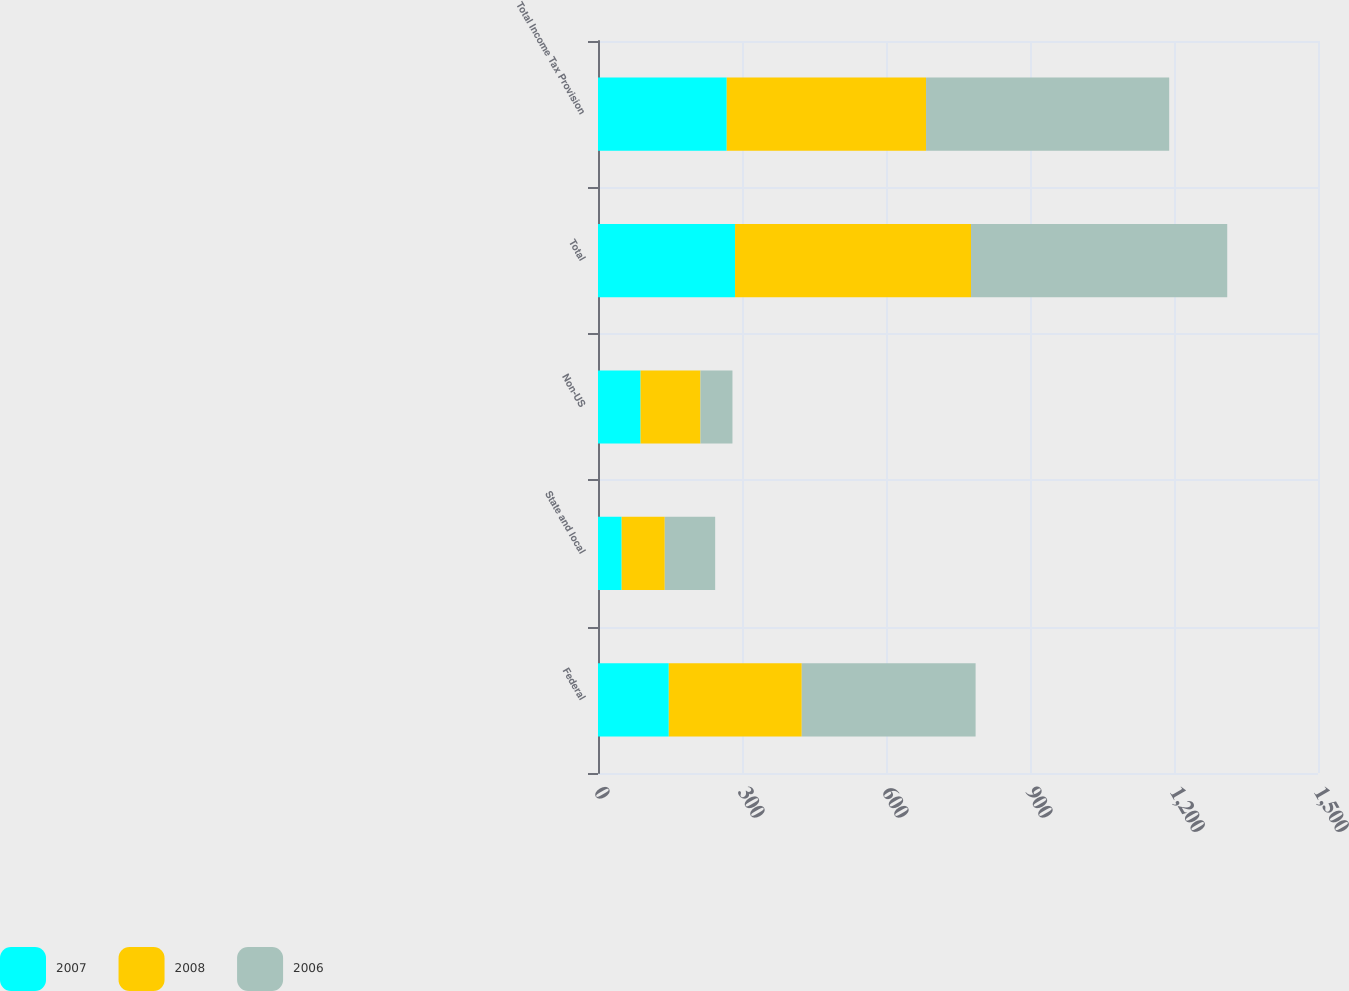Convert chart. <chart><loc_0><loc_0><loc_500><loc_500><stacked_bar_chart><ecel><fcel>Federal<fcel>State and local<fcel>Non-US<fcel>Total<fcel>Total Income Tax Provision<nl><fcel>2007<fcel>147.5<fcel>49.3<fcel>88.7<fcel>285.5<fcel>268.2<nl><fcel>2008<fcel>277<fcel>89.8<fcel>124.8<fcel>491.6<fcel>415.2<nl><fcel>2006<fcel>362.2<fcel>105<fcel>66.6<fcel>533.8<fcel>506.6<nl></chart> 